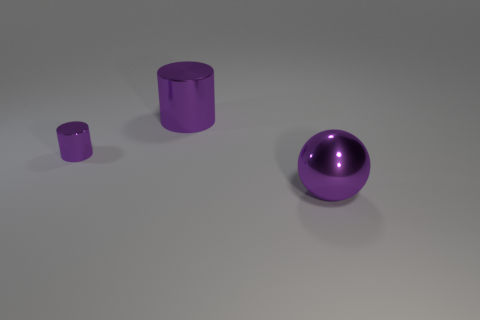Add 1 metallic balls. How many objects exist? 4 Subtract all cylinders. How many objects are left? 1 Subtract 1 cylinders. How many cylinders are left? 1 Add 1 small metallic objects. How many small metallic objects are left? 2 Add 2 purple cylinders. How many purple cylinders exist? 4 Subtract 0 cyan cubes. How many objects are left? 3 Subtract all green spheres. Subtract all blue blocks. How many spheres are left? 1 Subtract all tiny cylinders. Subtract all blue cylinders. How many objects are left? 2 